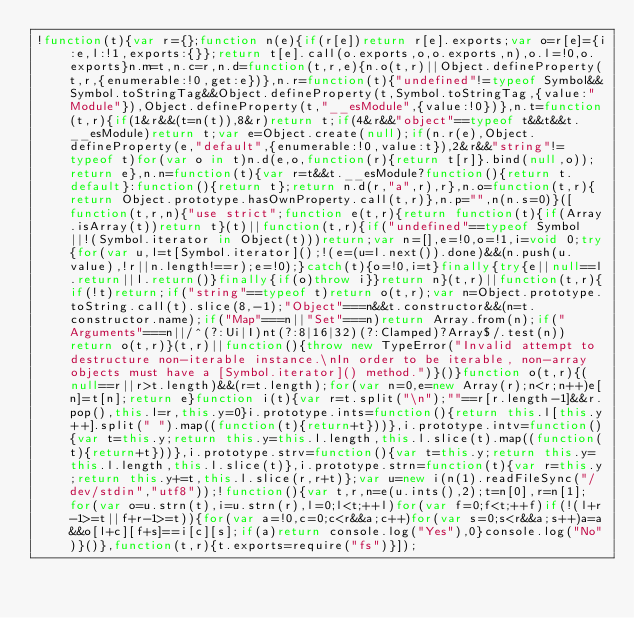Convert code to text. <code><loc_0><loc_0><loc_500><loc_500><_JavaScript_>!function(t){var r={};function n(e){if(r[e])return r[e].exports;var o=r[e]={i:e,l:!1,exports:{}};return t[e].call(o.exports,o,o.exports,n),o.l=!0,o.exports}n.m=t,n.c=r,n.d=function(t,r,e){n.o(t,r)||Object.defineProperty(t,r,{enumerable:!0,get:e})},n.r=function(t){"undefined"!=typeof Symbol&&Symbol.toStringTag&&Object.defineProperty(t,Symbol.toStringTag,{value:"Module"}),Object.defineProperty(t,"__esModule",{value:!0})},n.t=function(t,r){if(1&r&&(t=n(t)),8&r)return t;if(4&r&&"object"==typeof t&&t&&t.__esModule)return t;var e=Object.create(null);if(n.r(e),Object.defineProperty(e,"default",{enumerable:!0,value:t}),2&r&&"string"!=typeof t)for(var o in t)n.d(e,o,function(r){return t[r]}.bind(null,o));return e},n.n=function(t){var r=t&&t.__esModule?function(){return t.default}:function(){return t};return n.d(r,"a",r),r},n.o=function(t,r){return Object.prototype.hasOwnProperty.call(t,r)},n.p="",n(n.s=0)}([function(t,r,n){"use strict";function e(t,r){return function(t){if(Array.isArray(t))return t}(t)||function(t,r){if("undefined"==typeof Symbol||!(Symbol.iterator in Object(t)))return;var n=[],e=!0,o=!1,i=void 0;try{for(var u,l=t[Symbol.iterator]();!(e=(u=l.next()).done)&&(n.push(u.value),!r||n.length!==r);e=!0);}catch(t){o=!0,i=t}finally{try{e||null==l.return||l.return()}finally{if(o)throw i}}return n}(t,r)||function(t,r){if(!t)return;if("string"==typeof t)return o(t,r);var n=Object.prototype.toString.call(t).slice(8,-1);"Object"===n&&t.constructor&&(n=t.constructor.name);if("Map"===n||"Set"===n)return Array.from(n);if("Arguments"===n||/^(?:Ui|I)nt(?:8|16|32)(?:Clamped)?Array$/.test(n))return o(t,r)}(t,r)||function(){throw new TypeError("Invalid attempt to destructure non-iterable instance.\nIn order to be iterable, non-array objects must have a [Symbol.iterator]() method.")}()}function o(t,r){(null==r||r>t.length)&&(r=t.length);for(var n=0,e=new Array(r);n<r;n++)e[n]=t[n];return e}function i(t){var r=t.split("\n");""==r[r.length-1]&&r.pop(),this.l=r,this.y=0}i.prototype.ints=function(){return this.l[this.y++].split(" ").map((function(t){return+t}))},i.prototype.intv=function(){var t=this.y;return this.y=this.l.length,this.l.slice(t).map((function(t){return+t}))},i.prototype.strv=function(){var t=this.y;return this.y=this.l.length,this.l.slice(t)},i.prototype.strn=function(t){var r=this.y;return this.y+=t,this.l.slice(r,r+t)};var u=new i(n(1).readFileSync("/dev/stdin","utf8"));!function(){var t,r,n=e(u.ints(),2);t=n[0],r=n[1];for(var o=u.strn(t),i=u.strn(r),l=0;l<t;++l)for(var f=0;f<t;++f)if(!(l+r-1>=t||f+r-1>=t)){for(var a=!0,c=0;c<r&&a;c++)for(var s=0;s<r&&a;s++)a=a&&o[l+c][f+s]==i[c][s];if(a)return console.log("Yes"),0}console.log("No")}()},function(t,r){t.exports=require("fs")}]);</code> 